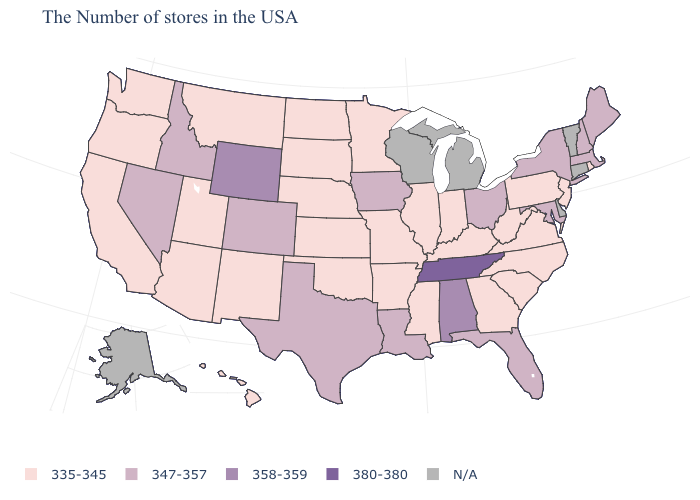Does Tennessee have the highest value in the USA?
Be succinct. Yes. Does the map have missing data?
Short answer required. Yes. Which states have the lowest value in the USA?
Quick response, please. Rhode Island, New Jersey, Pennsylvania, Virginia, North Carolina, South Carolina, West Virginia, Georgia, Kentucky, Indiana, Illinois, Mississippi, Missouri, Arkansas, Minnesota, Kansas, Nebraska, Oklahoma, South Dakota, North Dakota, New Mexico, Utah, Montana, Arizona, California, Washington, Oregon, Hawaii. What is the value of Massachusetts?
Keep it brief. 347-357. What is the value of Delaware?
Keep it brief. N/A. Among the states that border Massachusetts , which have the highest value?
Be succinct. New Hampshire, New York. What is the highest value in the West ?
Give a very brief answer. 358-359. Name the states that have a value in the range 380-380?
Write a very short answer. Tennessee. Does Arizona have the highest value in the USA?
Short answer required. No. Which states have the highest value in the USA?
Concise answer only. Tennessee. Name the states that have a value in the range 358-359?
Write a very short answer. Alabama, Wyoming. What is the value of Pennsylvania?
Write a very short answer. 335-345. Name the states that have a value in the range 347-357?
Be succinct. Maine, Massachusetts, New Hampshire, New York, Maryland, Ohio, Florida, Louisiana, Iowa, Texas, Colorado, Idaho, Nevada. What is the value of Hawaii?
Write a very short answer. 335-345. What is the highest value in the Northeast ?
Short answer required. 347-357. 